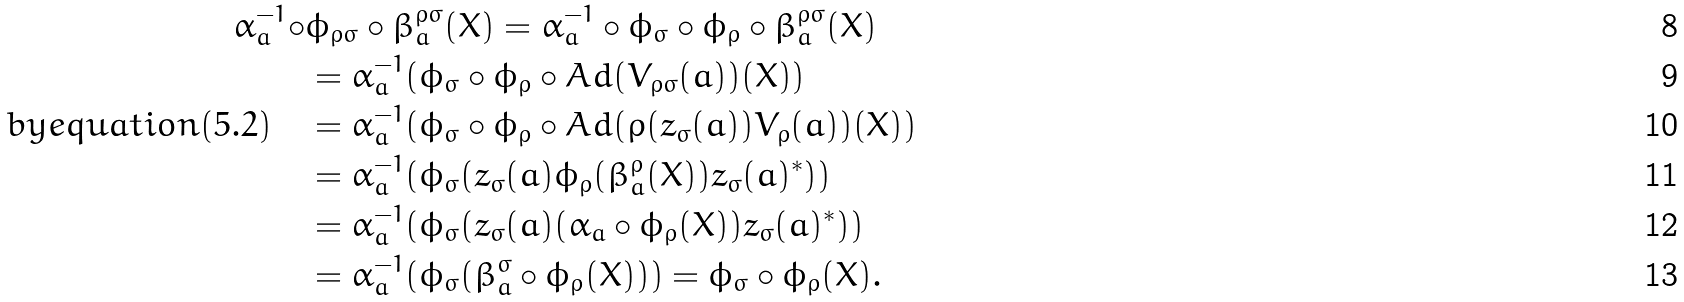<formula> <loc_0><loc_0><loc_500><loc_500>\alpha _ { a } ^ { - 1 } \circ & \phi _ { \rho \sigma } \circ \beta ^ { \rho \sigma } _ { a } ( X ) = \alpha _ { a } ^ { - 1 } \circ \phi _ { \sigma } \circ \phi _ { \rho } \circ \beta ^ { \rho \sigma } _ { a } ( X ) \\ & = \alpha _ { a } ^ { - 1 } ( \phi _ { \sigma } \circ \phi _ { \rho } \circ A d ( V _ { \rho \sigma } ( a ) ) ( X ) ) \\ b y e q u a t i o n ( 5 . 2 ) \quad & = \alpha _ { a } ^ { - 1 } ( \phi _ { \sigma } \circ \phi _ { \rho } \circ A d ( \rho ( z _ { \sigma } ( a ) ) V _ { \rho } ( a ) ) ( X ) ) \\ & = \alpha _ { a } ^ { - 1 } ( \phi _ { \sigma } ( z _ { \sigma } ( a ) \phi _ { \rho } ( \beta ^ { \rho } _ { a } ( X ) ) z _ { \sigma } ( a ) ^ { * } ) ) \\ & = \alpha _ { a } ^ { - 1 } ( \phi _ { \sigma } ( z _ { \sigma } ( a ) ( \alpha _ { a } \circ \phi _ { \rho } ( X ) ) z _ { \sigma } ( a ) ^ { * } ) ) \\ & = \alpha _ { a } ^ { - 1 } ( \phi _ { \sigma } ( \beta ^ { \sigma } _ { a } \circ \phi _ { \rho } ( X ) ) ) = \phi _ { \sigma } \circ \phi _ { \rho } ( X ) .</formula> 